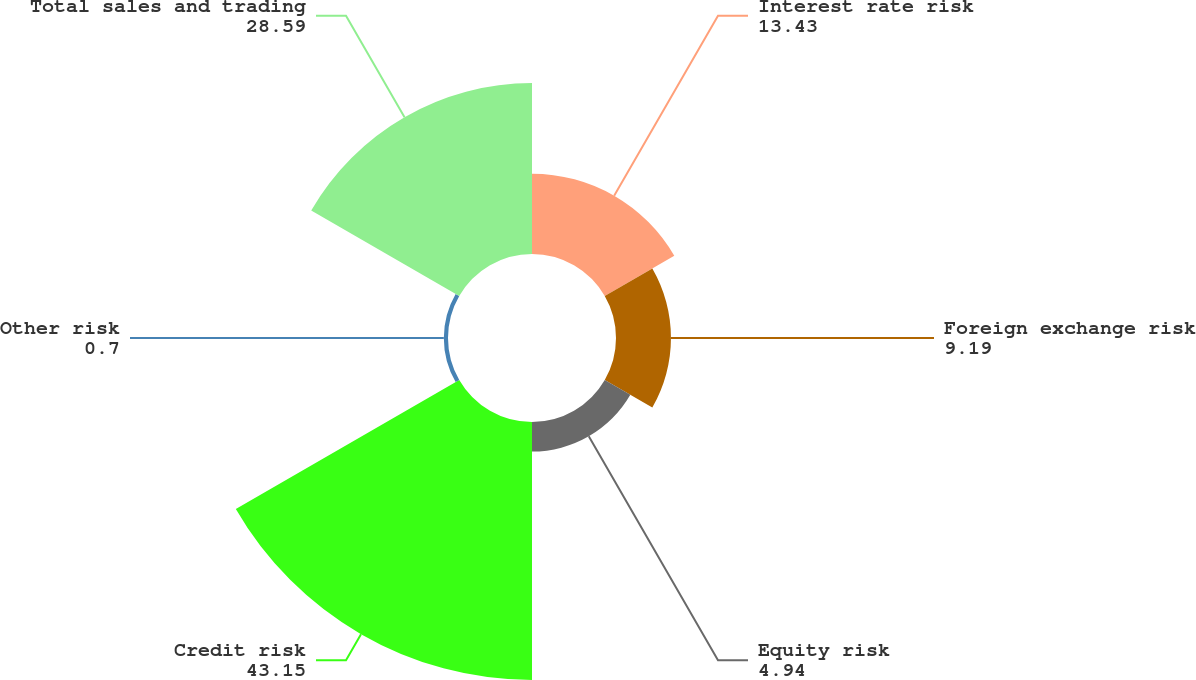<chart> <loc_0><loc_0><loc_500><loc_500><pie_chart><fcel>Interest rate risk<fcel>Foreign exchange risk<fcel>Equity risk<fcel>Credit risk<fcel>Other risk<fcel>Total sales and trading<nl><fcel>13.43%<fcel>9.19%<fcel>4.94%<fcel>43.15%<fcel>0.7%<fcel>28.59%<nl></chart> 